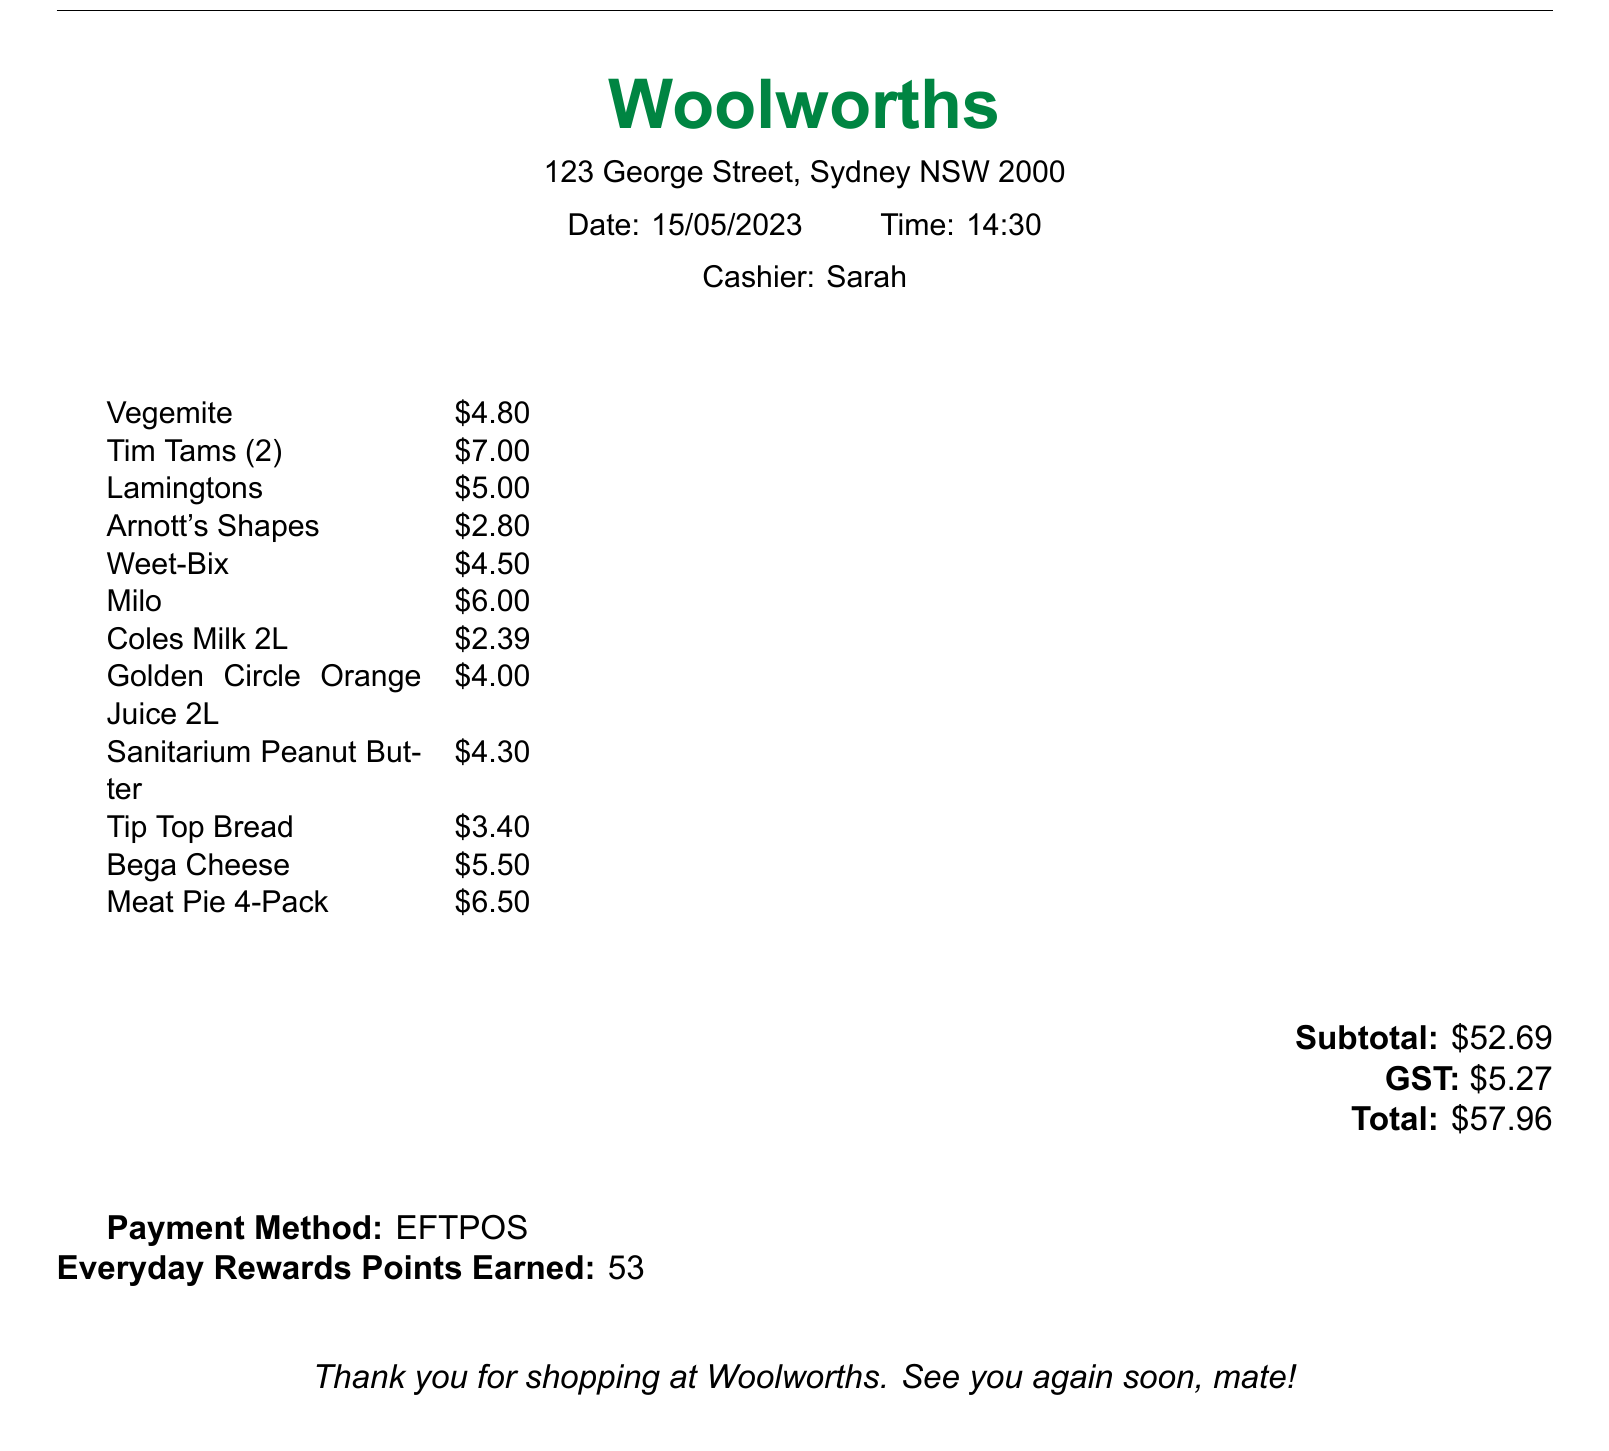What is the store name? The store name is prominently displayed at the top of the receipt.
Answer: Woolworths Who was the cashier? The name of the cashier is mentioned under the date and time section.
Answer: Sarah When was the receipt issued? The receipt date is noted clearly on the document.
Answer: 15/05/2023 What is the total amount? The total amount payable is provided at the end of the receipt.
Answer: $57.96 How much GST was paid? The GST amount appears right before the total on the receipt.
Answer: $5.27 What was the quantity of Tim Tams purchased? The quantity of Tim Tams is stated in parentheses next to the item on the receipt.
Answer: 2 What is the subtotal before tax? The subtotal is calculated before GST and is explicitly stated in the document.
Answer: $52.69 Which loyalty program is mentioned? The loyalty program mentioned is listed near the payment method section.
Answer: Everyday Rewards What type of payment was used? The payment method is stated clearly at the bottom of the receipt.
Answer: EFTPOS 